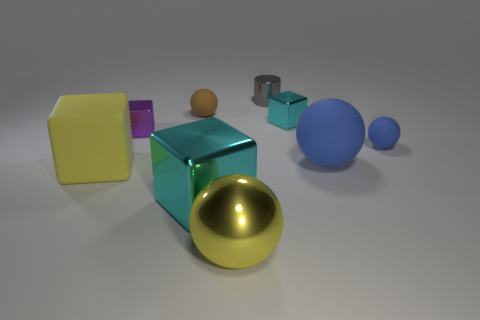Are there any small brown objects made of the same material as the big yellow block?
Your response must be concise. Yes. What is the shape of the small thing that is in front of the small gray cylinder and behind the tiny cyan thing?
Your answer should be compact. Sphere. How many small objects are either blue rubber things or cylinders?
Ensure brevity in your answer.  2. What material is the small brown sphere?
Make the answer very short. Rubber. How many other objects are the same shape as the small cyan metal thing?
Offer a terse response. 3. The shiny ball has what size?
Your answer should be very brief. Large. What size is the thing that is both to the right of the big cyan metallic cube and in front of the large rubber block?
Ensure brevity in your answer.  Large. What is the shape of the big matte object on the left side of the large yellow metallic object?
Offer a terse response. Cube. Are the gray cylinder and the big yellow object in front of the large yellow block made of the same material?
Give a very brief answer. Yes. Does the small brown rubber thing have the same shape as the tiny blue matte object?
Keep it short and to the point. Yes. 